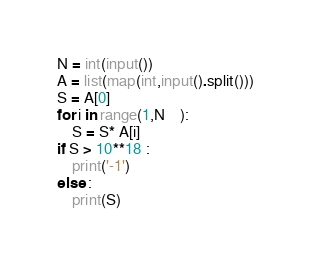Convert code to text. <code><loc_0><loc_0><loc_500><loc_500><_Python_>N = int(input())
A = list(map(int,input().split()))
S = A[0]
for i in range(1,N	):
    S = S* A[i]
if S > 10**18 :
    print('-1')
else :
    print(S)
</code> 